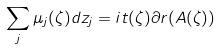Convert formula to latex. <formula><loc_0><loc_0><loc_500><loc_500>\sum _ { j } \mu _ { j } ( \zeta ) d z _ { j } = i t ( \zeta ) \partial r ( A ( \zeta ) )</formula> 